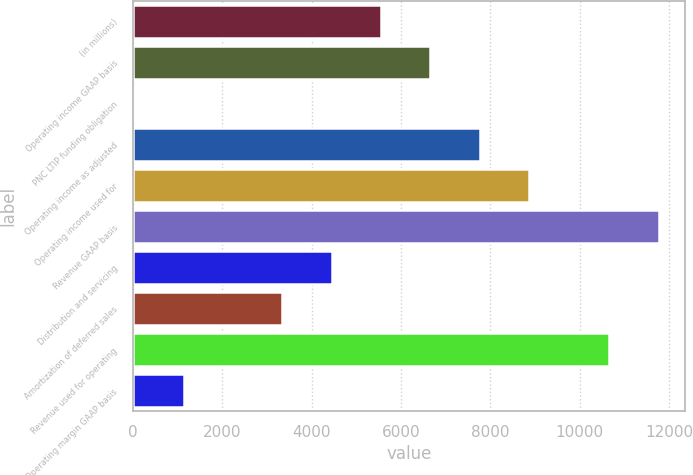Convert chart. <chart><loc_0><loc_0><loc_500><loc_500><bar_chart><fcel>(in millions)<fcel>Operating income GAAP basis<fcel>PNC LTIP funding obligation<fcel>Operating income as adjusted<fcel>Operating income used for<fcel>Revenue GAAP basis<fcel>Distribution and servicing<fcel>Amortization of deferred sales<fcel>Revenue used for operating<fcel>Operating margin GAAP basis<nl><fcel>5556.5<fcel>6661.4<fcel>32<fcel>7766.3<fcel>8871.2<fcel>11765.9<fcel>4451.6<fcel>3346.7<fcel>10661<fcel>1136.9<nl></chart> 